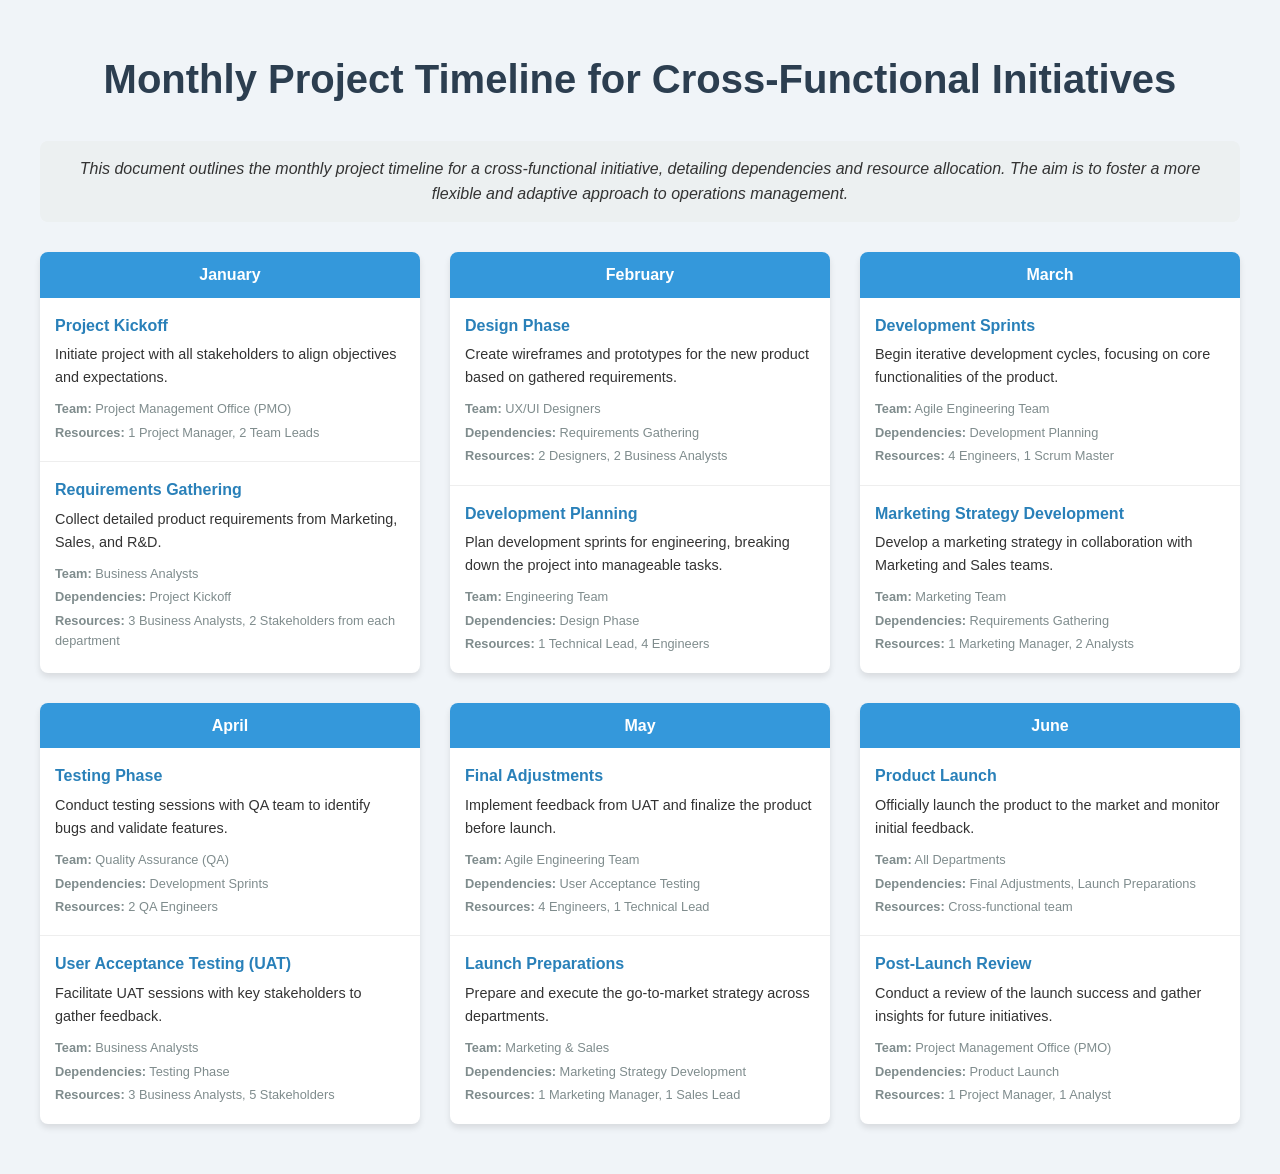What is the first task in January? The first task in January is "Project Kickoff."
Answer: Project Kickoff Who is responsible for the "Requirements Gathering" task? The "Requirements Gathering" task is handled by Business Analysts.
Answer: Business Analysts How many resources are allocated for the "Development Sprints"? The "Development Sprints" task requires 4 Engineers and 1 Scrum Master, totaling 5 resources.
Answer: 5 What is the dependency for the "Design Phase" task? The "Design Phase" task depends on the "Requirements Gathering."
Answer: Requirements Gathering How many stakeholders participate in the "User Acceptance Testing (UAT)"? The "User Acceptance Testing (UAT)" involves 5 Stakeholders.
Answer: 5 Stakeholders What month does the "Product Launch" occur? The "Product Launch" takes place in June.
Answer: June Which team manages the "Post-Launch Review"? The "Post-Launch Review" is managed by the Project Management Office (PMO).
Answer: Project Management Office (PMO) What is the outcome expected from the "Testing Phase"? The expected outcome of the "Testing Phase" is to identify bugs and validate features.
Answer: Identify bugs and validate features What task directly follows "Final Adjustments"? The task that directly follows "Final Adjustments" is "Launch Preparations."
Answer: Launch Preparations 